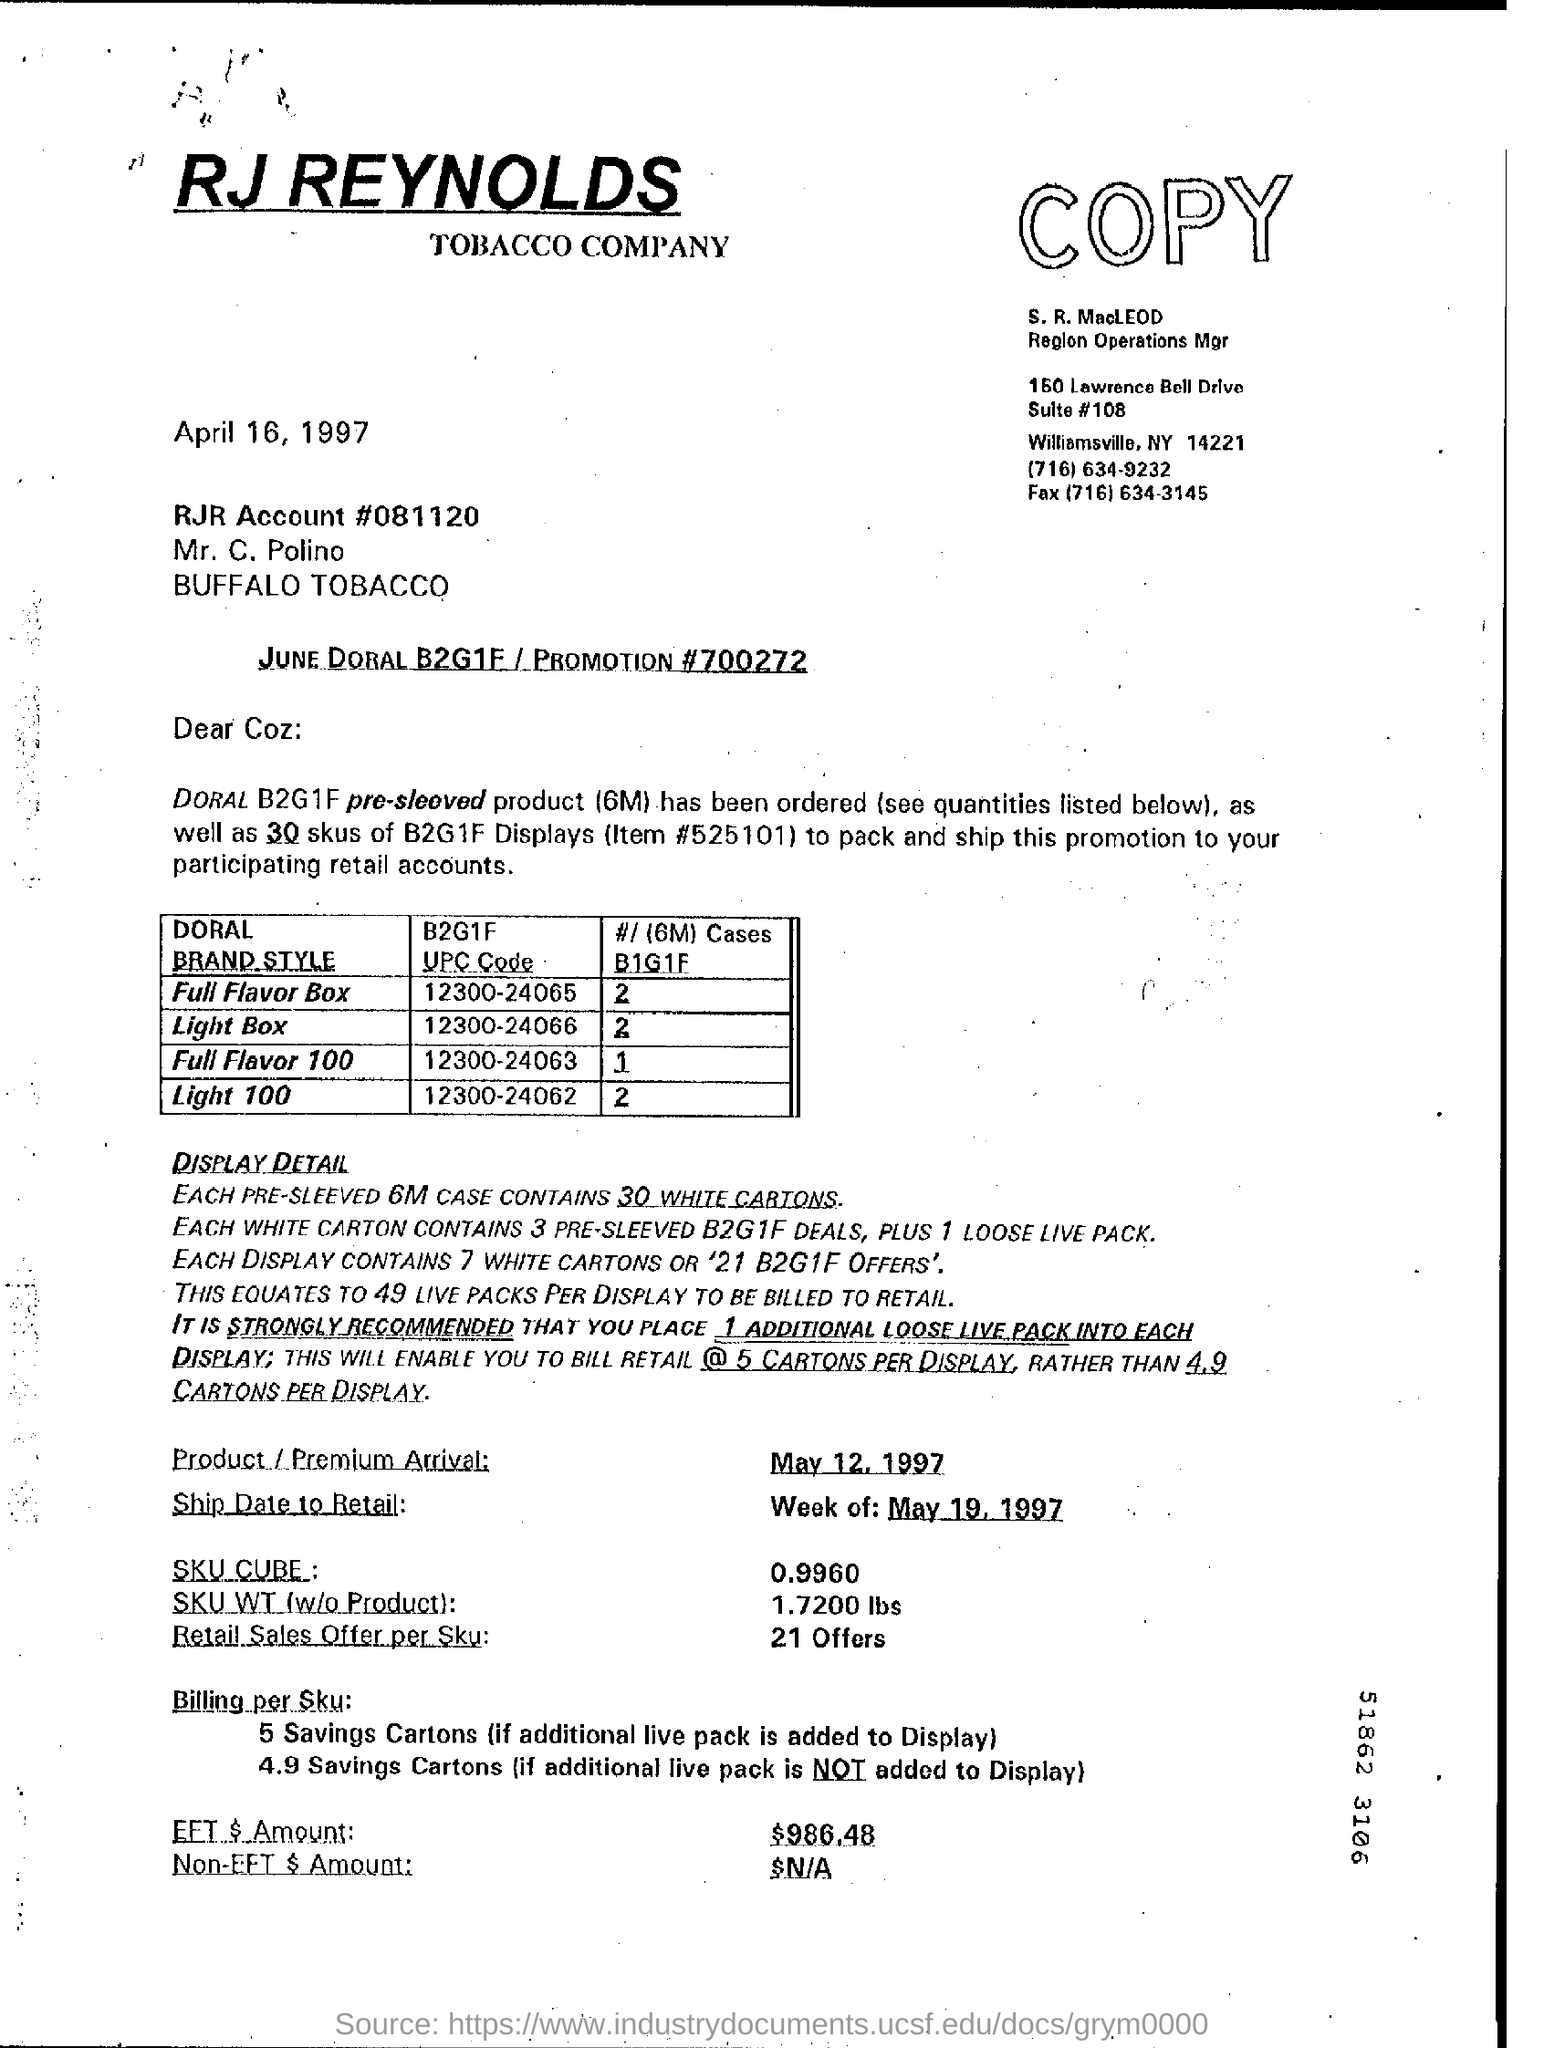Identify some key points in this picture. Each 6-meter case contains 30 white cartons. The product's arrival date is May 12, 1997. The fax number of the Region Operations Manager is (716) 634-3145. The B2G1F UPC code for "Full Flavour Box" is 12300-24065. 